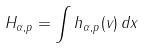Convert formula to latex. <formula><loc_0><loc_0><loc_500><loc_500>H _ { \alpha , p } = \int h _ { \alpha , p } ( v ) \, d x</formula> 